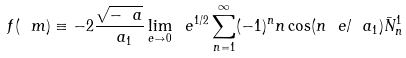Convert formula to latex. <formula><loc_0><loc_0><loc_500><loc_500>f ( \ m ) \equiv - 2 \frac { \sqrt { - \ a } } { \ a _ { 1 } } \lim _ { e \to 0 } \ e ^ { 1 / 2 } \sum _ { n = 1 } ^ { \infty } ( - 1 ) ^ { n } n \cos ( n \ e / \ a _ { 1 } ) \bar { N } ^ { 1 } _ { n }</formula> 